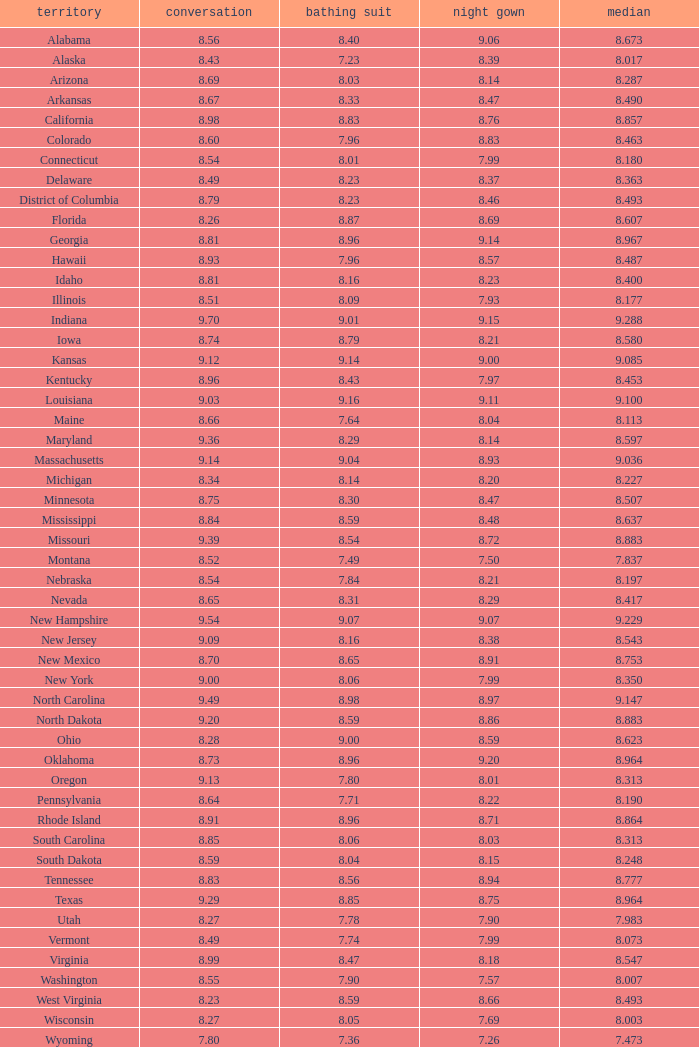Name the total number of swimsuits for evening gowns less than 8.21 and average of 8.453 with interview less than 9.09 1.0. 